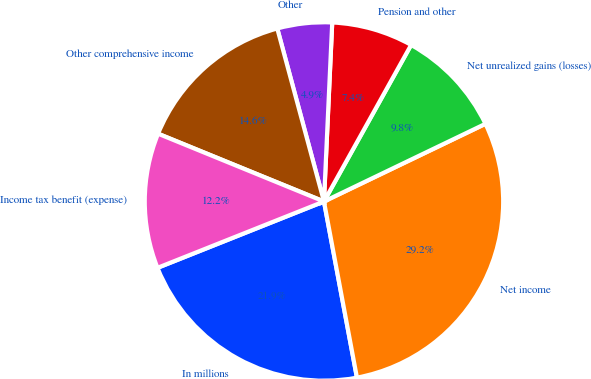Convert chart. <chart><loc_0><loc_0><loc_500><loc_500><pie_chart><fcel>In millions<fcel>Net income<fcel>Net unrealized gains (losses)<fcel>Pension and other<fcel>Other<fcel>Other comprehensive income<fcel>Income tax benefit (expense)<nl><fcel>21.91%<fcel>29.19%<fcel>9.78%<fcel>7.35%<fcel>4.93%<fcel>14.63%<fcel>12.21%<nl></chart> 